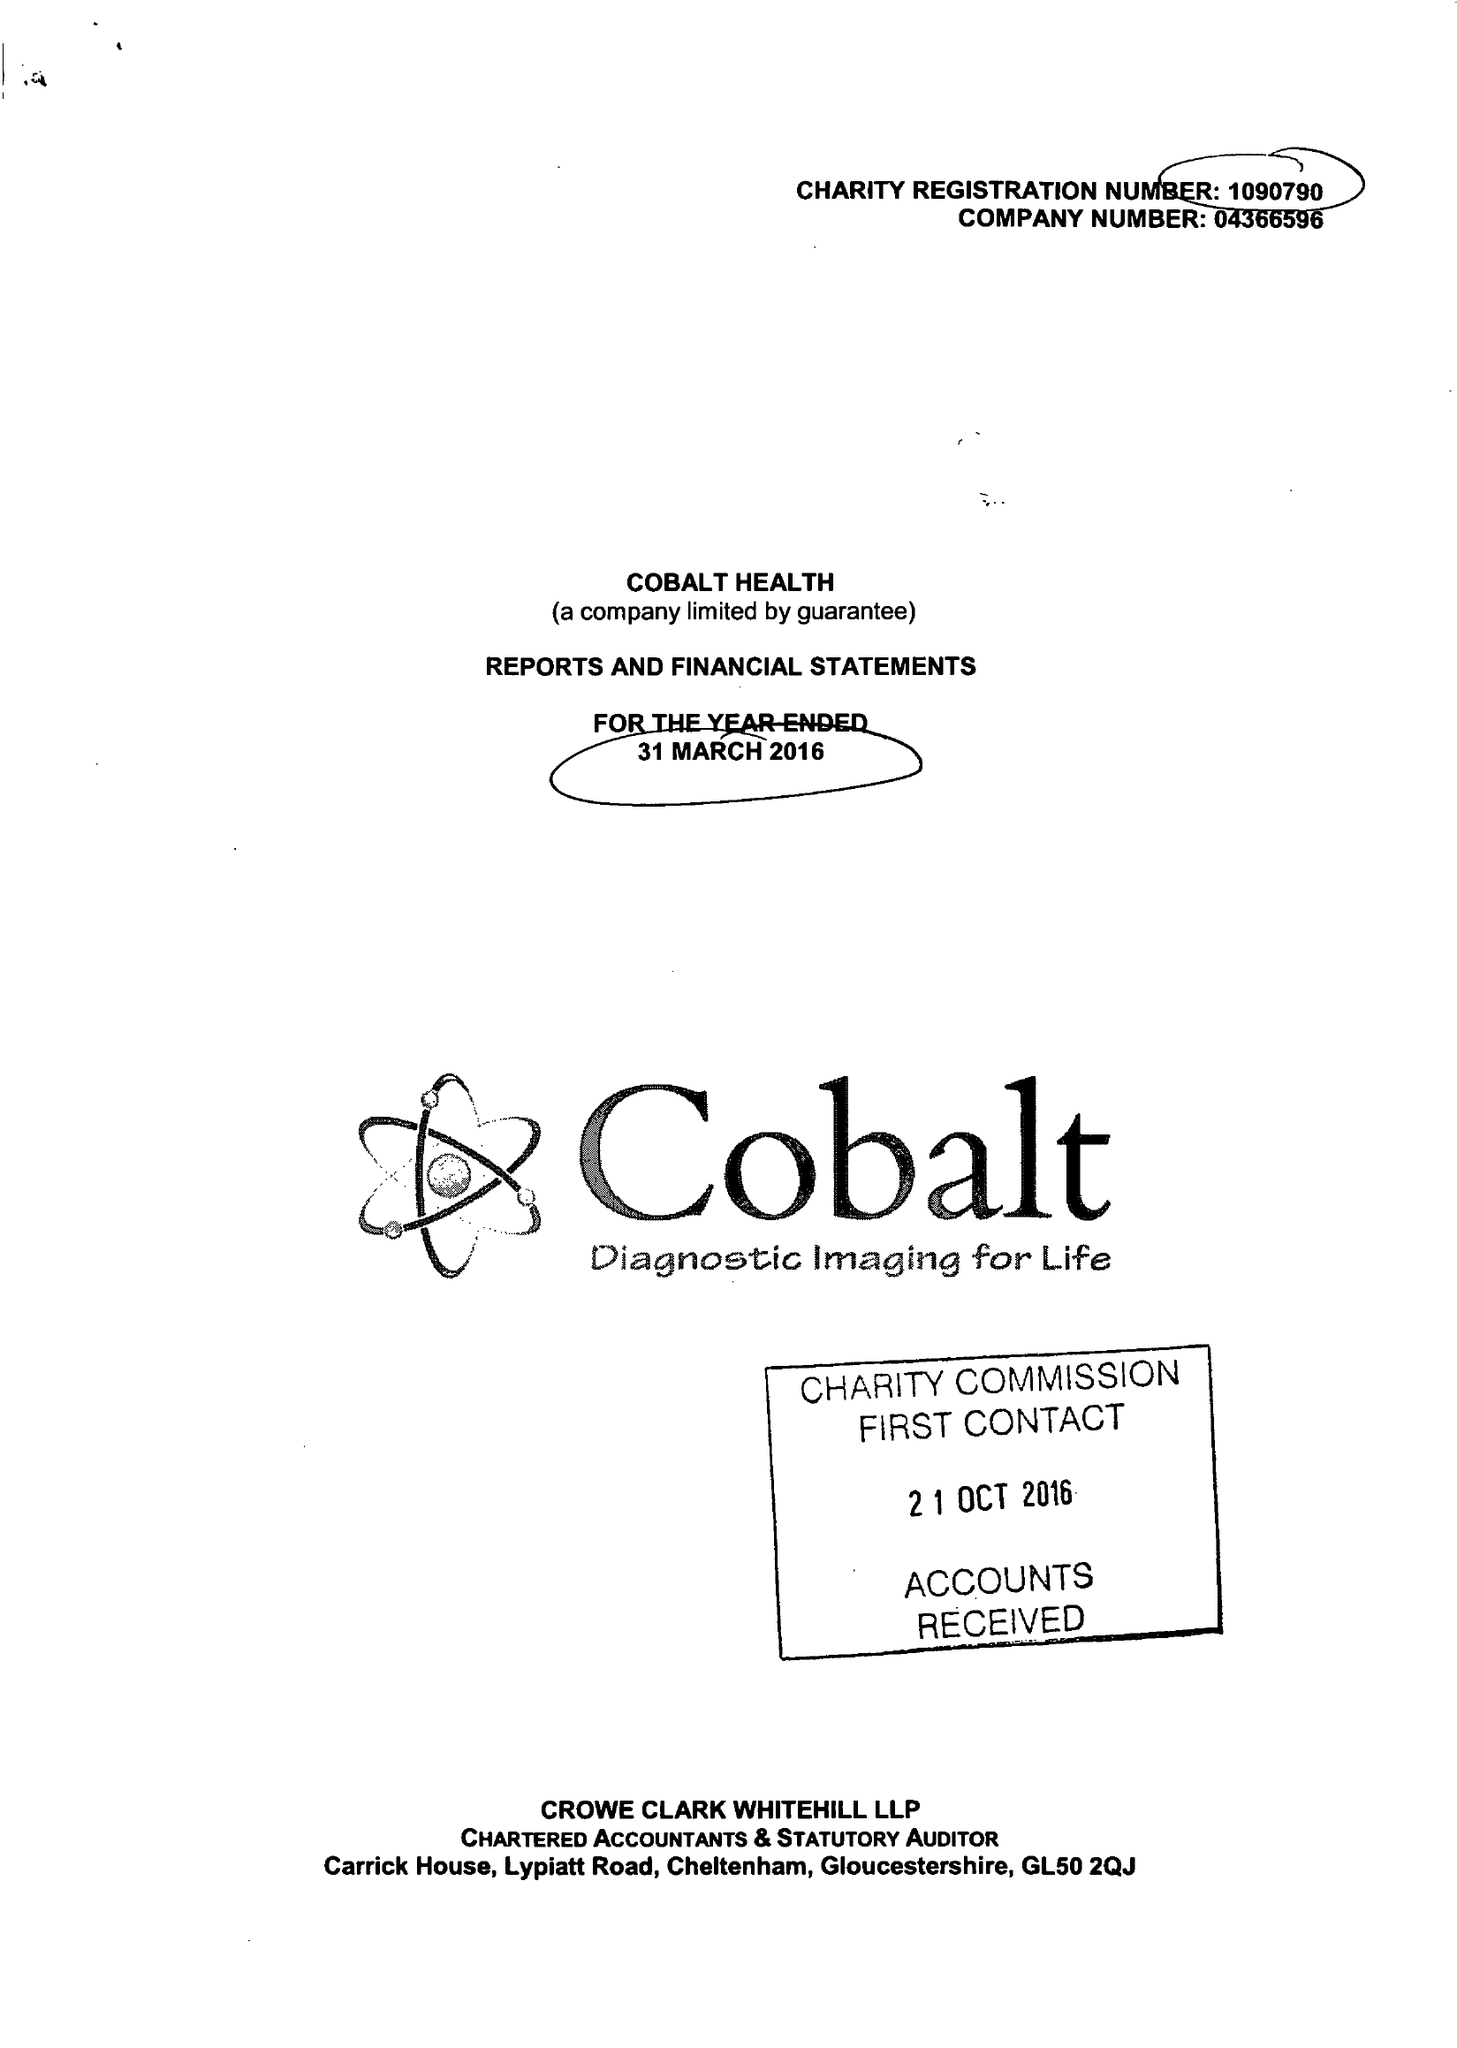What is the value for the report_date?
Answer the question using a single word or phrase. 2016-03-31 